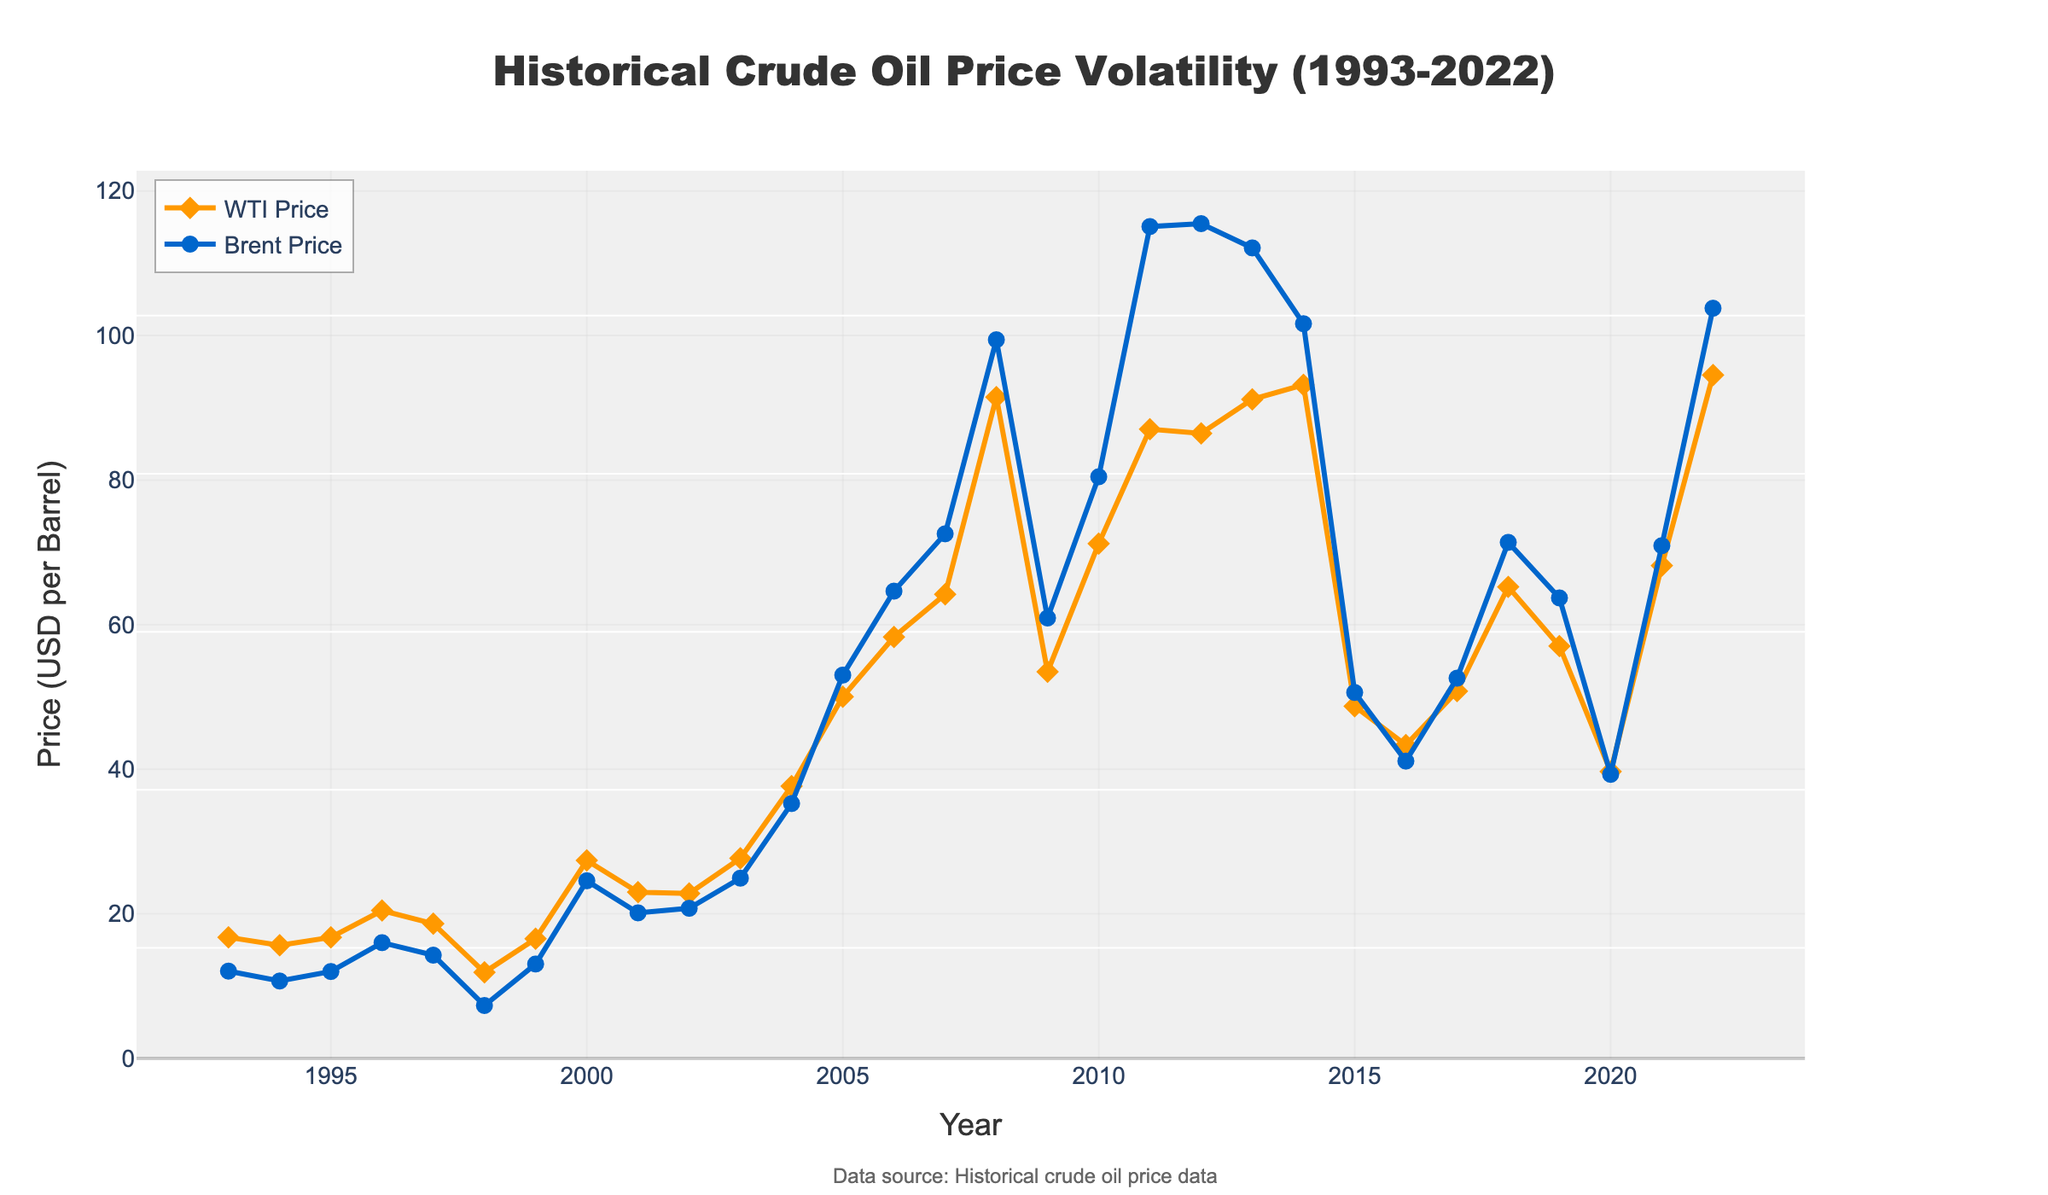Which year had the highest WTI price? The highest point on the WTI price line can be identified by looking at the peak. In the figure, the peak is around 2008.
Answer: 2008 What's the average price of Brent crude from 2010 to 2014? To find the average, sum the Brent prices for the years 2010, 2011, 2012, 2013, and 2014 and divide by 5. (79.61 + 111.26 + 111.63 + 108.56 + 98.97) / 5 = 102.406
Answer: 102.406 In which year did the WTI price see the most significant drop compared to the previous year? Compare the year-over-year changes and identify the most significant decrease. The largest drop is between 2014 and 2015, where WTI drops from 93.17 to 48.72.
Answer: 2015 How much more was the Brent price than the WTI price in 2011? Subtract the WTI price from the Brent price for the year 2011. 111.26 - 87.04 = 24.22
Answer: 24.22 Which benchmark had higher volatility in prices during the period 2005-2010? Compare the fluctuation range of prices for both WTI and Brent within the given period. Brent price shows greater swings, going from 54.52 in 2005 to 111.26 in 2011, while WTI ranges from 50.04 in 2005 to 91.48 in 2008.
Answer: Brent Did the WTI price ever surpass the Brent price? Scan the figure to identify if the WTI price line exceeds the Brent price line at any point. Based on the data, the WTI price did not surpass the Brent price at any point.
Answer: No What was the difference between the highest recorded prices for WTI and Brent? Identify the highest price points for WTI and Brent. WTI is highest at 91.48 in 2008, and Brent is highest at 111.63 in 2012. The difference is 111.63 - 91.48 = 20.15
Answer: 20.15 How did the prices of WTI and Brent change from 2019 to 2020? Refer to the chart for both WTI and Brent from 2019 to 2020. WTI dropped from 57.03 to 39.68, while Brent dropped from 64.28 to 41.96.
Answer: Both dropped Between 1998 and 2000, which year saw the highest increase in WTI prices compared to the previous year? Compare the year-over-year changes for 1998-1999 and 1999-2000. The increase from 1999 to 2000 was largest (16.56 to 27.39), a rise of 10.83.
Answer: 2000 